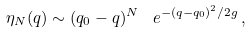<formula> <loc_0><loc_0><loc_500><loc_500>\eta _ { N } ( q ) \sim ( q _ { 0 } - q ) ^ { N } \, \ e ^ { - ( q - q _ { 0 } ) ^ { 2 } / 2 g } \, ,</formula> 